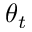<formula> <loc_0><loc_0><loc_500><loc_500>\theta _ { t }</formula> 